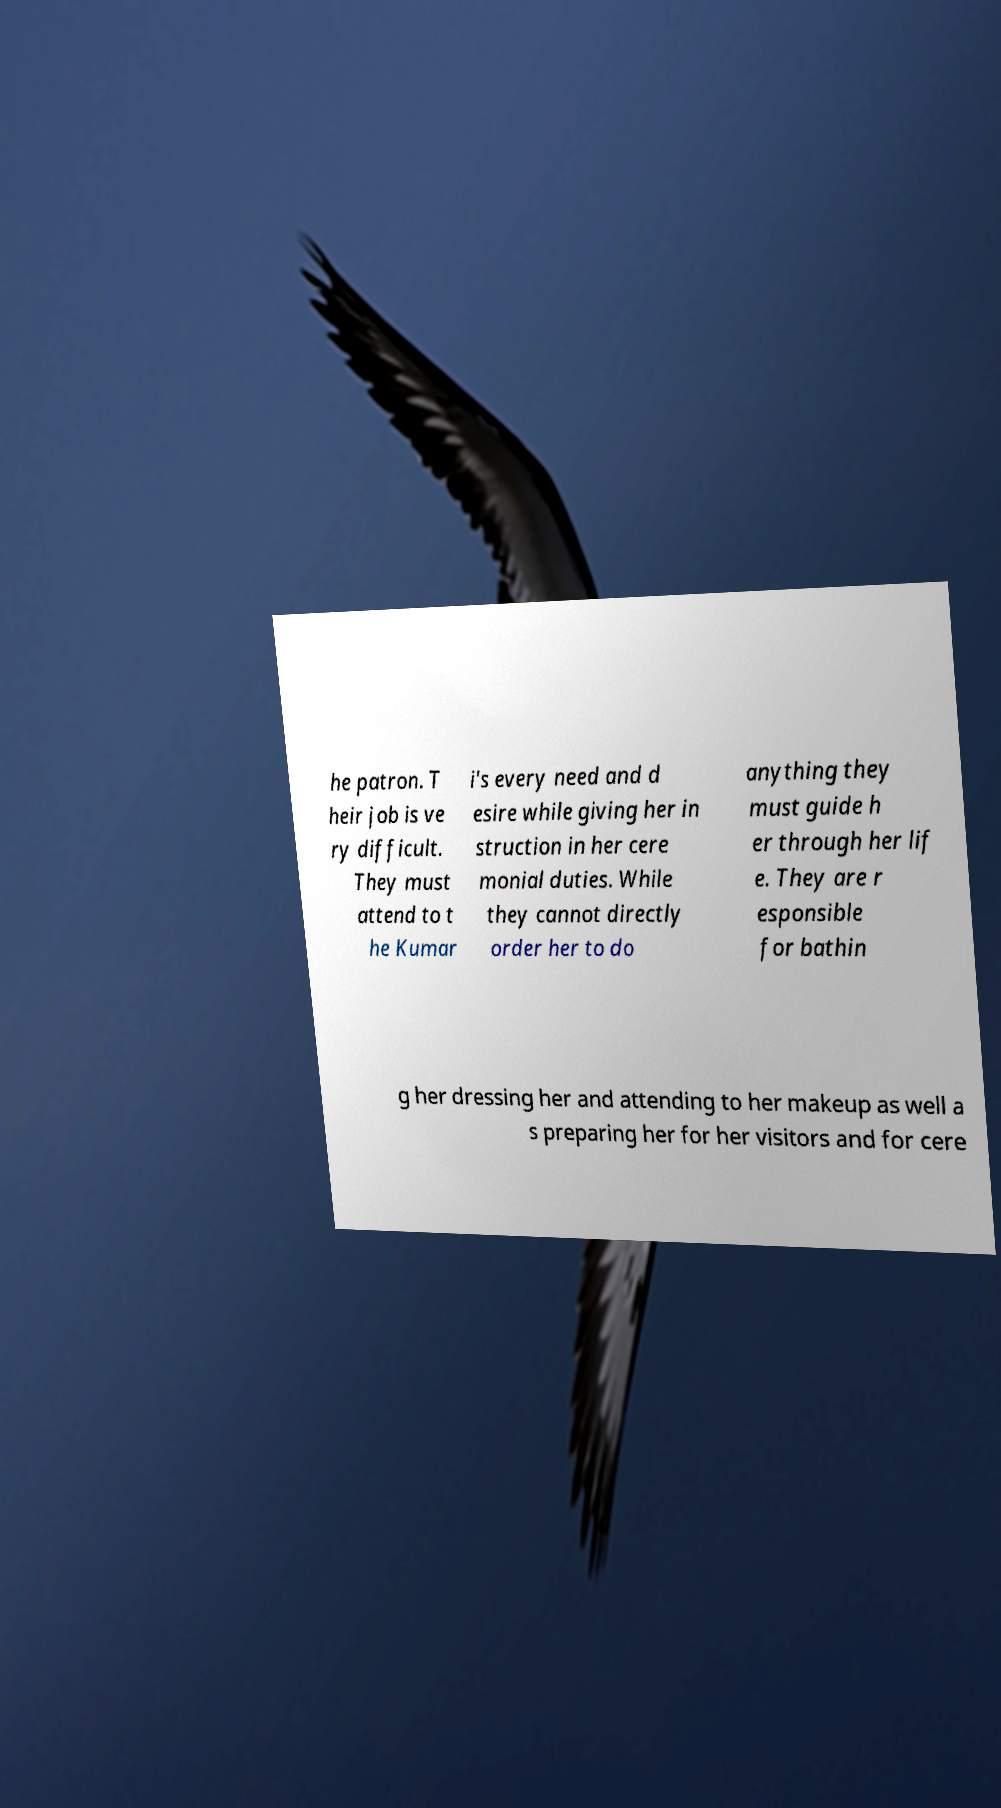Could you assist in decoding the text presented in this image and type it out clearly? he patron. T heir job is ve ry difficult. They must attend to t he Kumar i's every need and d esire while giving her in struction in her cere monial duties. While they cannot directly order her to do anything they must guide h er through her lif e. They are r esponsible for bathin g her dressing her and attending to her makeup as well a s preparing her for her visitors and for cere 